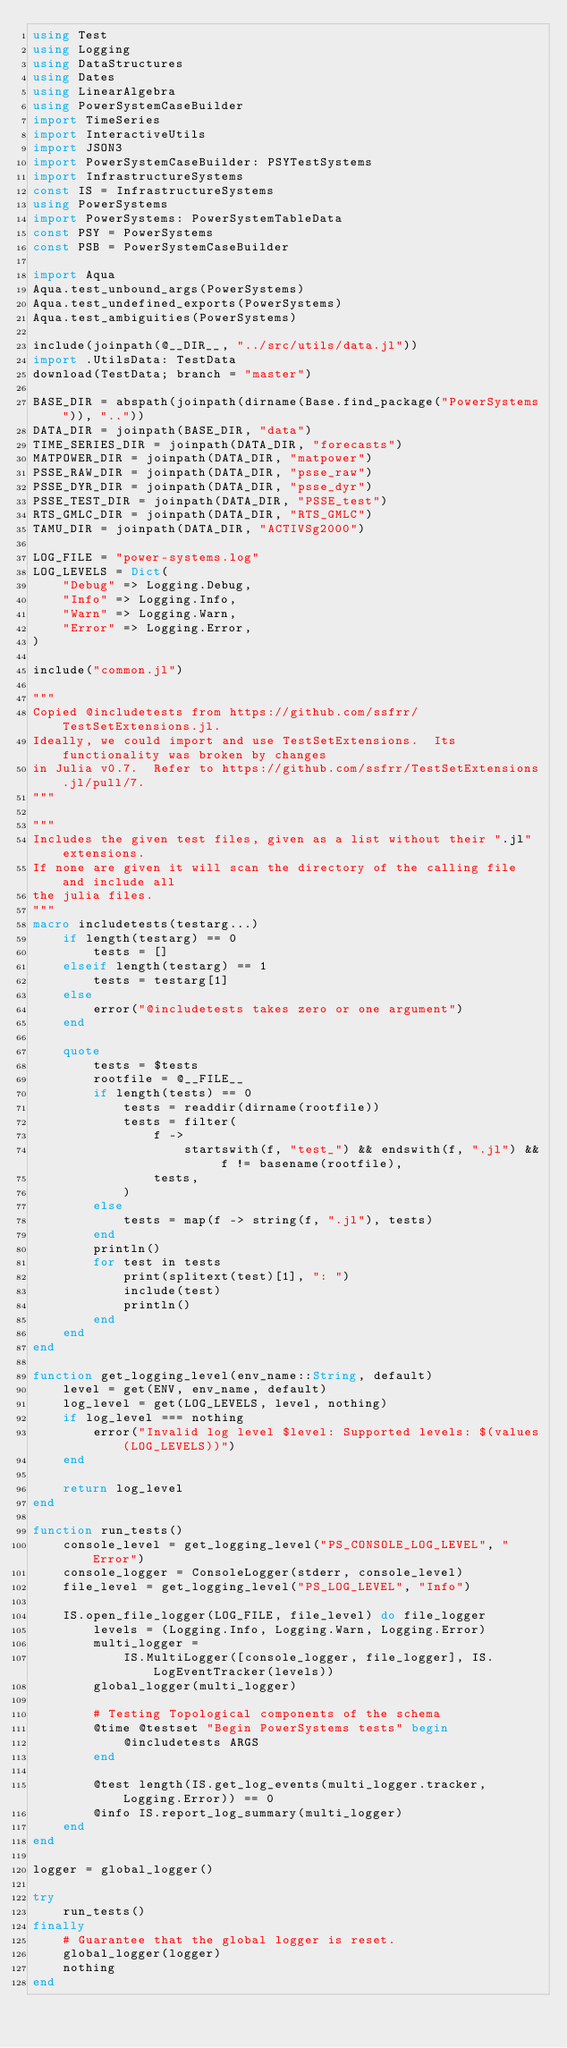<code> <loc_0><loc_0><loc_500><loc_500><_Julia_>using Test
using Logging
using DataStructures
using Dates
using LinearAlgebra
using PowerSystemCaseBuilder
import TimeSeries
import InteractiveUtils
import JSON3
import PowerSystemCaseBuilder: PSYTestSystems
import InfrastructureSystems
const IS = InfrastructureSystems
using PowerSystems
import PowerSystems: PowerSystemTableData
const PSY = PowerSystems
const PSB = PowerSystemCaseBuilder

import Aqua
Aqua.test_unbound_args(PowerSystems)
Aqua.test_undefined_exports(PowerSystems)
Aqua.test_ambiguities(PowerSystems)

include(joinpath(@__DIR__, "../src/utils/data.jl"))
import .UtilsData: TestData
download(TestData; branch = "master")

BASE_DIR = abspath(joinpath(dirname(Base.find_package("PowerSystems")), ".."))
DATA_DIR = joinpath(BASE_DIR, "data")
TIME_SERIES_DIR = joinpath(DATA_DIR, "forecasts")
MATPOWER_DIR = joinpath(DATA_DIR, "matpower")
PSSE_RAW_DIR = joinpath(DATA_DIR, "psse_raw")
PSSE_DYR_DIR = joinpath(DATA_DIR, "psse_dyr")
PSSE_TEST_DIR = joinpath(DATA_DIR, "PSSE_test")
RTS_GMLC_DIR = joinpath(DATA_DIR, "RTS_GMLC")
TAMU_DIR = joinpath(DATA_DIR, "ACTIVSg2000")

LOG_FILE = "power-systems.log"
LOG_LEVELS = Dict(
    "Debug" => Logging.Debug,
    "Info" => Logging.Info,
    "Warn" => Logging.Warn,
    "Error" => Logging.Error,
)

include("common.jl")

"""
Copied @includetests from https://github.com/ssfrr/TestSetExtensions.jl.
Ideally, we could import and use TestSetExtensions.  Its functionality was broken by changes
in Julia v0.7.  Refer to https://github.com/ssfrr/TestSetExtensions.jl/pull/7.
"""

"""
Includes the given test files, given as a list without their ".jl" extensions.
If none are given it will scan the directory of the calling file and include all
the julia files.
"""
macro includetests(testarg...)
    if length(testarg) == 0
        tests = []
    elseif length(testarg) == 1
        tests = testarg[1]
    else
        error("@includetests takes zero or one argument")
    end

    quote
        tests = $tests
        rootfile = @__FILE__
        if length(tests) == 0
            tests = readdir(dirname(rootfile))
            tests = filter(
                f ->
                    startswith(f, "test_") && endswith(f, ".jl") && f != basename(rootfile),
                tests,
            )
        else
            tests = map(f -> string(f, ".jl"), tests)
        end
        println()
        for test in tests
            print(splitext(test)[1], ": ")
            include(test)
            println()
        end
    end
end

function get_logging_level(env_name::String, default)
    level = get(ENV, env_name, default)
    log_level = get(LOG_LEVELS, level, nothing)
    if log_level === nothing
        error("Invalid log level $level: Supported levels: $(values(LOG_LEVELS))")
    end

    return log_level
end

function run_tests()
    console_level = get_logging_level("PS_CONSOLE_LOG_LEVEL", "Error")
    console_logger = ConsoleLogger(stderr, console_level)
    file_level = get_logging_level("PS_LOG_LEVEL", "Info")

    IS.open_file_logger(LOG_FILE, file_level) do file_logger
        levels = (Logging.Info, Logging.Warn, Logging.Error)
        multi_logger =
            IS.MultiLogger([console_logger, file_logger], IS.LogEventTracker(levels))
        global_logger(multi_logger)

        # Testing Topological components of the schema
        @time @testset "Begin PowerSystems tests" begin
            @includetests ARGS
        end

        @test length(IS.get_log_events(multi_logger.tracker, Logging.Error)) == 0
        @info IS.report_log_summary(multi_logger)
    end
end

logger = global_logger()

try
    run_tests()
finally
    # Guarantee that the global logger is reset.
    global_logger(logger)
    nothing
end
</code> 